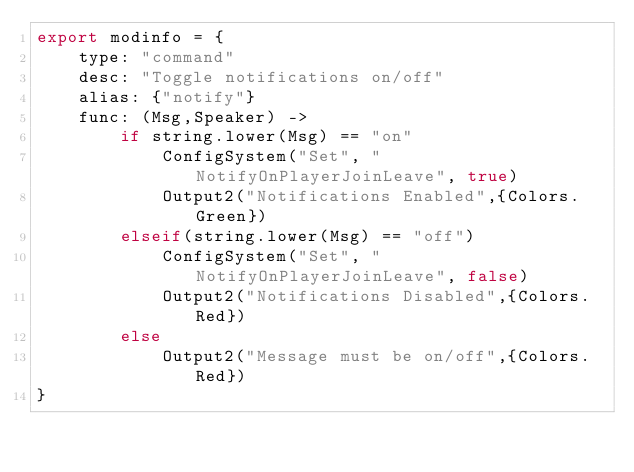<code> <loc_0><loc_0><loc_500><loc_500><_MoonScript_>export modinfo = {
	type: "command"
	desc: "Toggle notifications on/off"
	alias: {"notify"}
	func: (Msg,Speaker) ->
		if string.lower(Msg) == "on"
			ConfigSystem("Set", "NotifyOnPlayerJoinLeave", true)
			Output2("Notifications Enabled",{Colors.Green})
		elseif(string.lower(Msg) == "off")
			ConfigSystem("Set", "NotifyOnPlayerJoinLeave", false)
			Output2("Notifications Disabled",{Colors.Red})
		else 
			Output2("Message must be on/off",{Colors.Red})
}</code> 